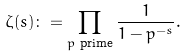Convert formula to latex. <formula><loc_0><loc_0><loc_500><loc_500>\zeta ( s ) \colon = \prod _ { p \text { prime} } \frac { 1 } { 1 - p ^ { - s } } .</formula> 